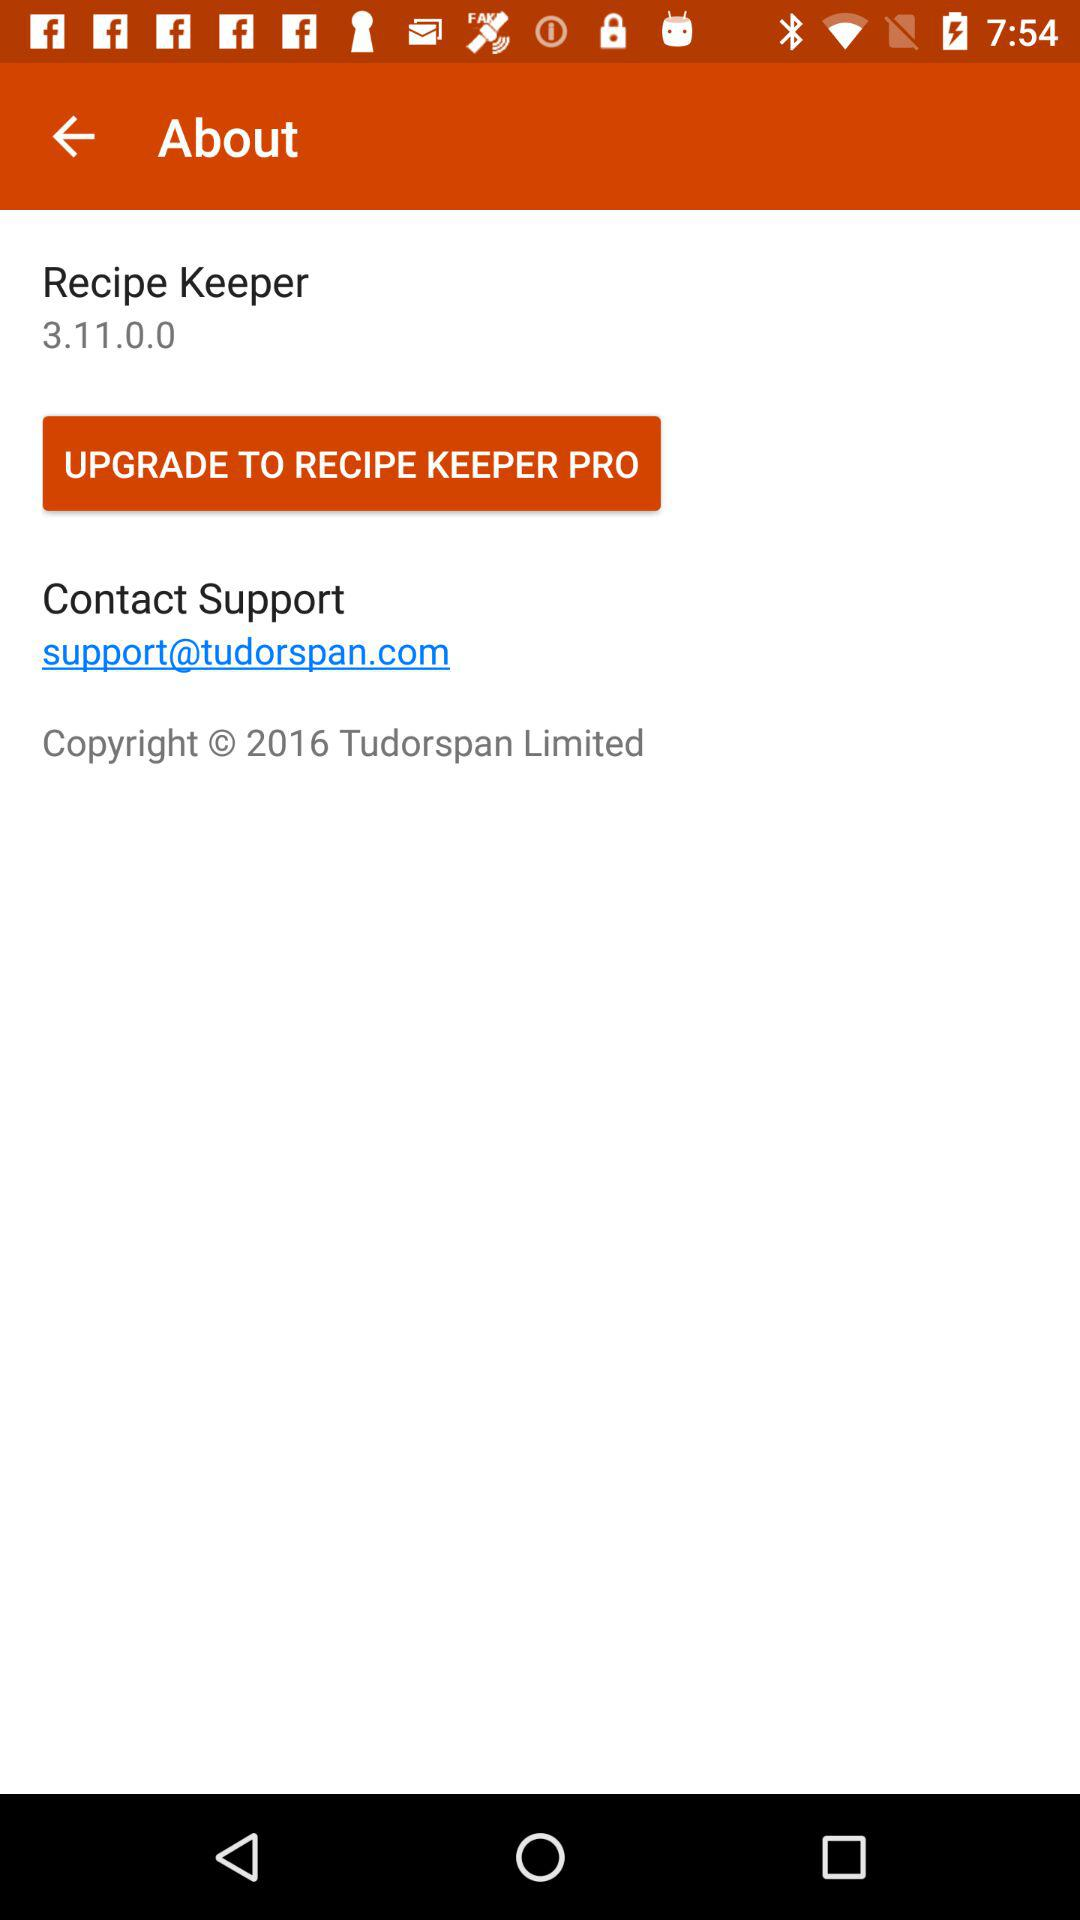What is the contact support email address given on the screen? The contact support email address is support@tudorspan.com. 